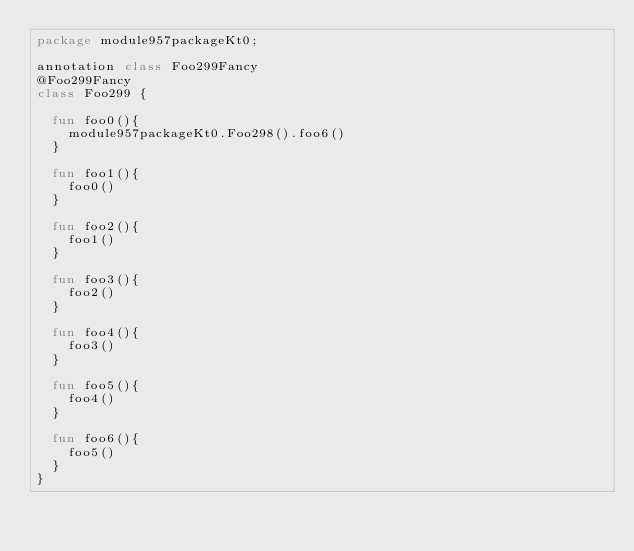Convert code to text. <code><loc_0><loc_0><loc_500><loc_500><_Kotlin_>package module957packageKt0;

annotation class Foo299Fancy
@Foo299Fancy
class Foo299 {

  fun foo0(){
    module957packageKt0.Foo298().foo6()
  }

  fun foo1(){
    foo0()
  }

  fun foo2(){
    foo1()
  }

  fun foo3(){
    foo2()
  }

  fun foo4(){
    foo3()
  }

  fun foo5(){
    foo4()
  }

  fun foo6(){
    foo5()
  }
}</code> 